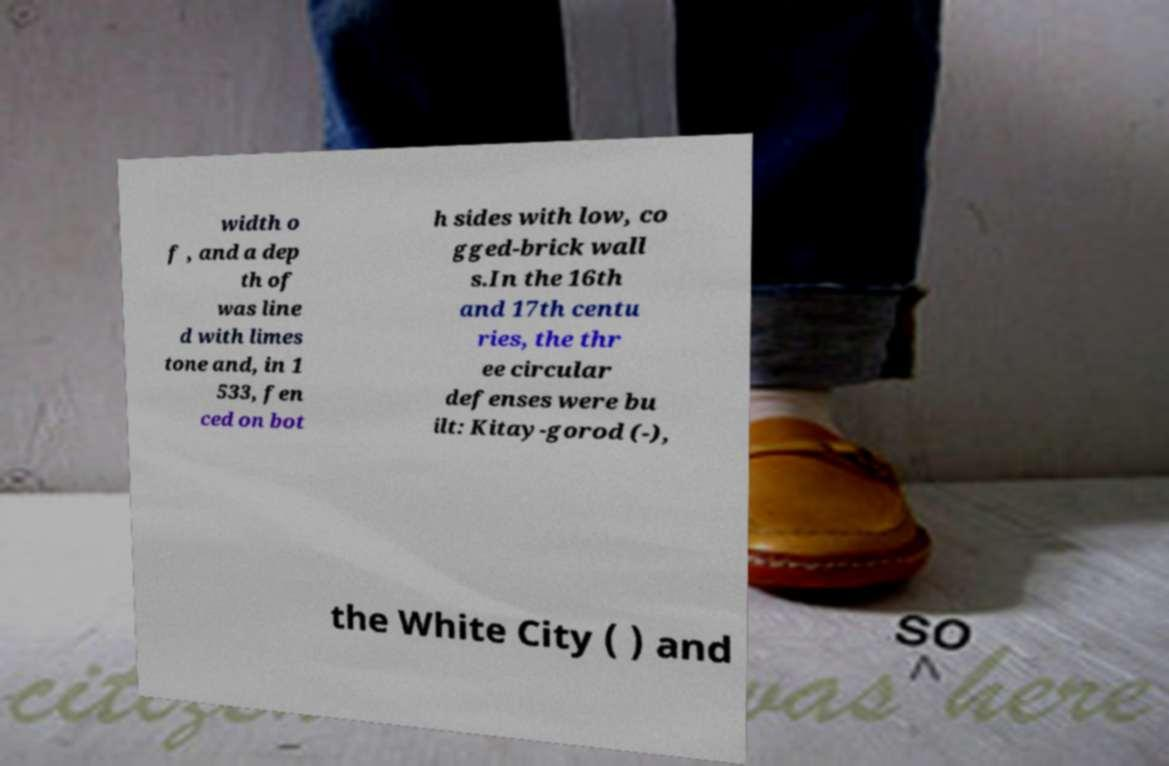Can you accurately transcribe the text from the provided image for me? width o f , and a dep th of was line d with limes tone and, in 1 533, fen ced on bot h sides with low, co gged-brick wall s.In the 16th and 17th centu ries, the thr ee circular defenses were bu ilt: Kitay-gorod (-), the White City ( ) and 